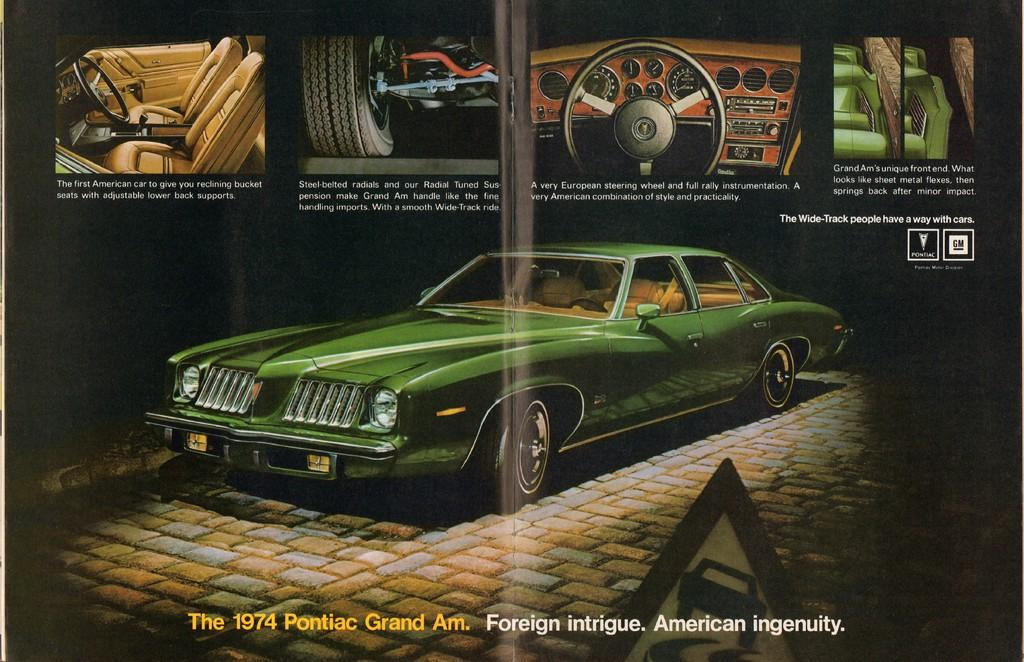What is depicted on the poster in the image? The poster contains a car. What features of the car can be seen in the image? The car has steering wheels, seats, and wheels. Is there any text on the poster? Yes, there is text on the poster. What type of discussion is taking place between the father and the car in the image? There is no father or discussion present in the image; it only features a poster with a car and text. 